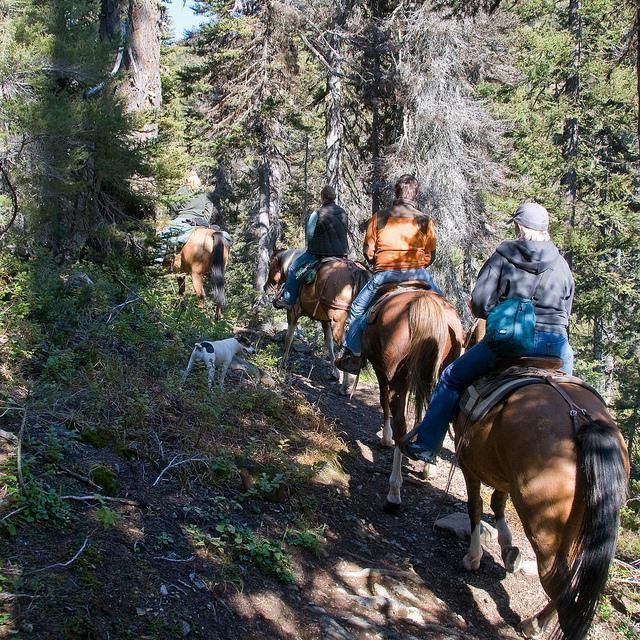Why are some trees here leafless?
Make your selection from the four choices given to correctly answer the question.
Options: They're dead, spring, sap suckers, summer. They're dead. 